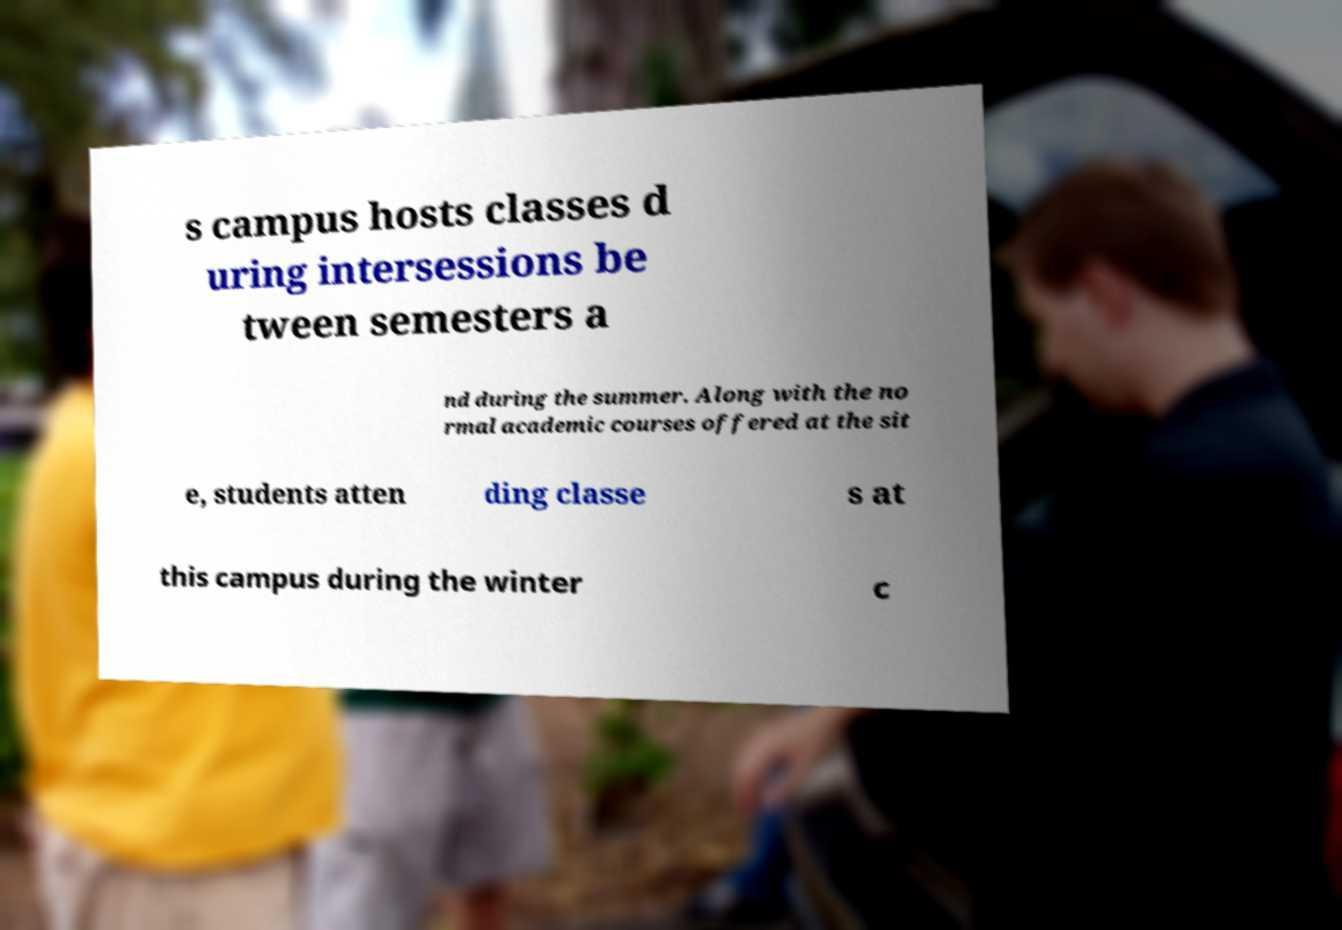For documentation purposes, I need the text within this image transcribed. Could you provide that? s campus hosts classes d uring intersessions be tween semesters a nd during the summer. Along with the no rmal academic courses offered at the sit e, students atten ding classe s at this campus during the winter c 